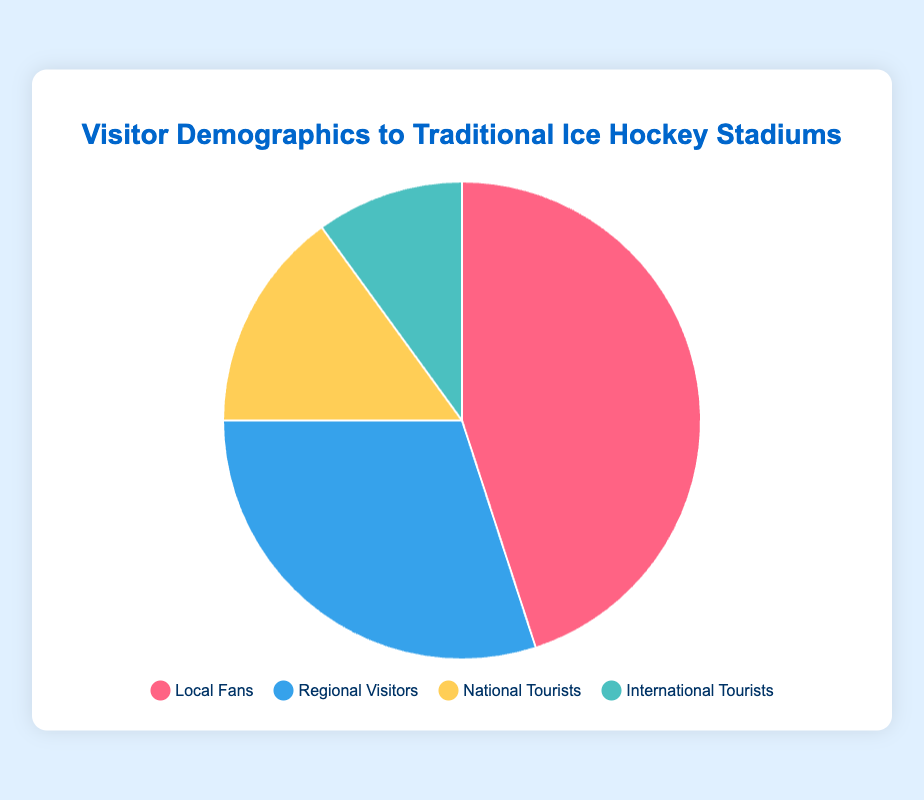What percentage of visitors at Madison Square Garden are local fans? The slice representing local fans is labeled 'Local Fans' with a percentage shown directly on the pie chart.
Answer: 45% How does the proportion of regional visitors at United Center compare to Bell Centre? The pie chart shows the percentage of regional visitors for both stadiums: United Center has 35% and Bell Centre has 20%.
Answer: United Center has more regional visitors What is the total percentage of tourists (national + international) at Scotiabank Arena? Add the percentages for national tourists (15%) and international tourists (10%) as shown on the pie chart. 15% + 10% = 25%.
Answer: 25% Which stadium has the highest percentage of local fans? Examine the percentages for local fans in all slices: Madison Square Garden (45%), Scotiabank Arena (50%), Bell Centre (55%), United Center (40%).
Answer: Bell Centre How does the proportion of international tourists compare across all stadiums? All slices for international tourists in different stadiums show 10%, making them equal.
Answer: Equal across all stadiums What is the difference between the percentage of local fans and regional visitors at Madison Square Garden? Subtract the percentage of regional visitors (30%) from local fans (45%) at Madison Square Garden: 45% - 30% = 15%.
Answer: 15% If you combine the percentages of national and international tourists at United Center, does it exceed the percentage of local fans? Combine national tourists (15%) and international tourists (10%) and compare to local fans (40%): 15% + 10% = 25%, which is less than 40%.
Answer: No Which stadium has the smallest proportion of local fans and what is it? Check percentages for local fans: Madison Square Garden (45%), Scotiabank Arena (50%), Bell Centre (55%), United Center (40%). United Center has the smallest proportion.
Answer: United Center, 40% What is the average percentage of regional visitors across all stadiums? Sum the percentages of regional visitors for all stadiums: 30% + 25% + 20% + 35% = 110%, then divide by 4: 110% / 4 = 27.5%.
Answer: 27.5% Which stadium has the most evenly distributed visitor demographics? Compare the percentages for each visitor type in each stadium. United Center has the most balanced distribution with 40%, 35%, 15%, and 10%.
Answer: United Center 